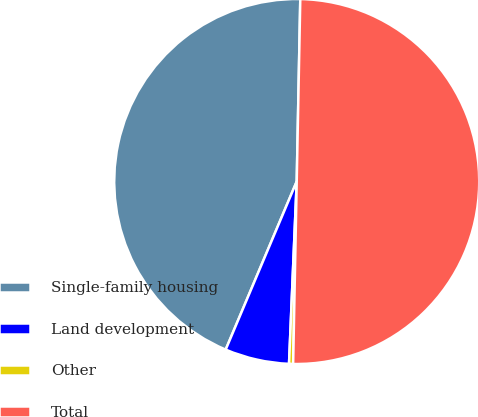Convert chart to OTSL. <chart><loc_0><loc_0><loc_500><loc_500><pie_chart><fcel>Single-family housing<fcel>Land development<fcel>Other<fcel>Total<nl><fcel>43.95%<fcel>5.69%<fcel>0.36%<fcel>50.0%<nl></chart> 